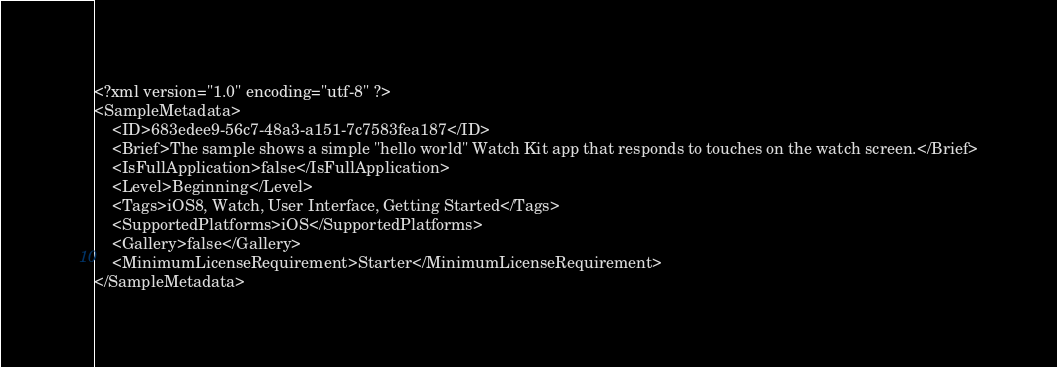Convert code to text. <code><loc_0><loc_0><loc_500><loc_500><_XML_><?xml version="1.0" encoding="utf-8" ?>
<SampleMetadata>
	<ID>683edee9-56c7-48a3-a151-7c7583fea187</ID>
	<Brief>The sample shows a simple "hello world" Watch Kit app that responds to touches on the watch screen.</Brief>
	<IsFullApplication>false</IsFullApplication>
	<Level>Beginning</Level>
	<Tags>iOS8, Watch, User Interface, Getting Started</Tags>
	<SupportedPlatforms>iOS</SupportedPlatforms>
	<Gallery>false</Gallery>
	<MinimumLicenseRequirement>Starter</MinimumLicenseRequirement>
</SampleMetadata>
</code> 